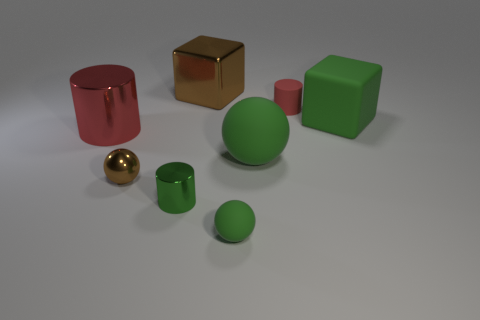What size is the red cylinder that is behind the large block that is in front of the red cylinder that is right of the big green ball?
Give a very brief answer. Small. What is the size of the object that is both behind the large red metal object and in front of the tiny red thing?
Your answer should be compact. Large. There is a block that is in front of the metallic block; is it the same color as the large block on the left side of the big rubber sphere?
Make the answer very short. No. How many red cylinders are right of the big cylinder?
Your answer should be very brief. 1. Is there a green rubber ball in front of the tiny cylinder on the left side of the brown metallic object behind the brown ball?
Give a very brief answer. Yes. How many metallic cylinders are the same size as the green metal object?
Your answer should be compact. 0. What material is the sphere that is in front of the sphere left of the green metallic object?
Provide a succinct answer. Rubber. The large thing that is behind the large rubber object behind the metallic cylinder behind the green cylinder is what shape?
Your answer should be very brief. Cube. Do the brown shiny thing in front of the big red object and the large green thing that is on the left side of the tiny red rubber object have the same shape?
Your answer should be very brief. Yes. How many other objects are there of the same material as the large sphere?
Your answer should be compact. 3. 